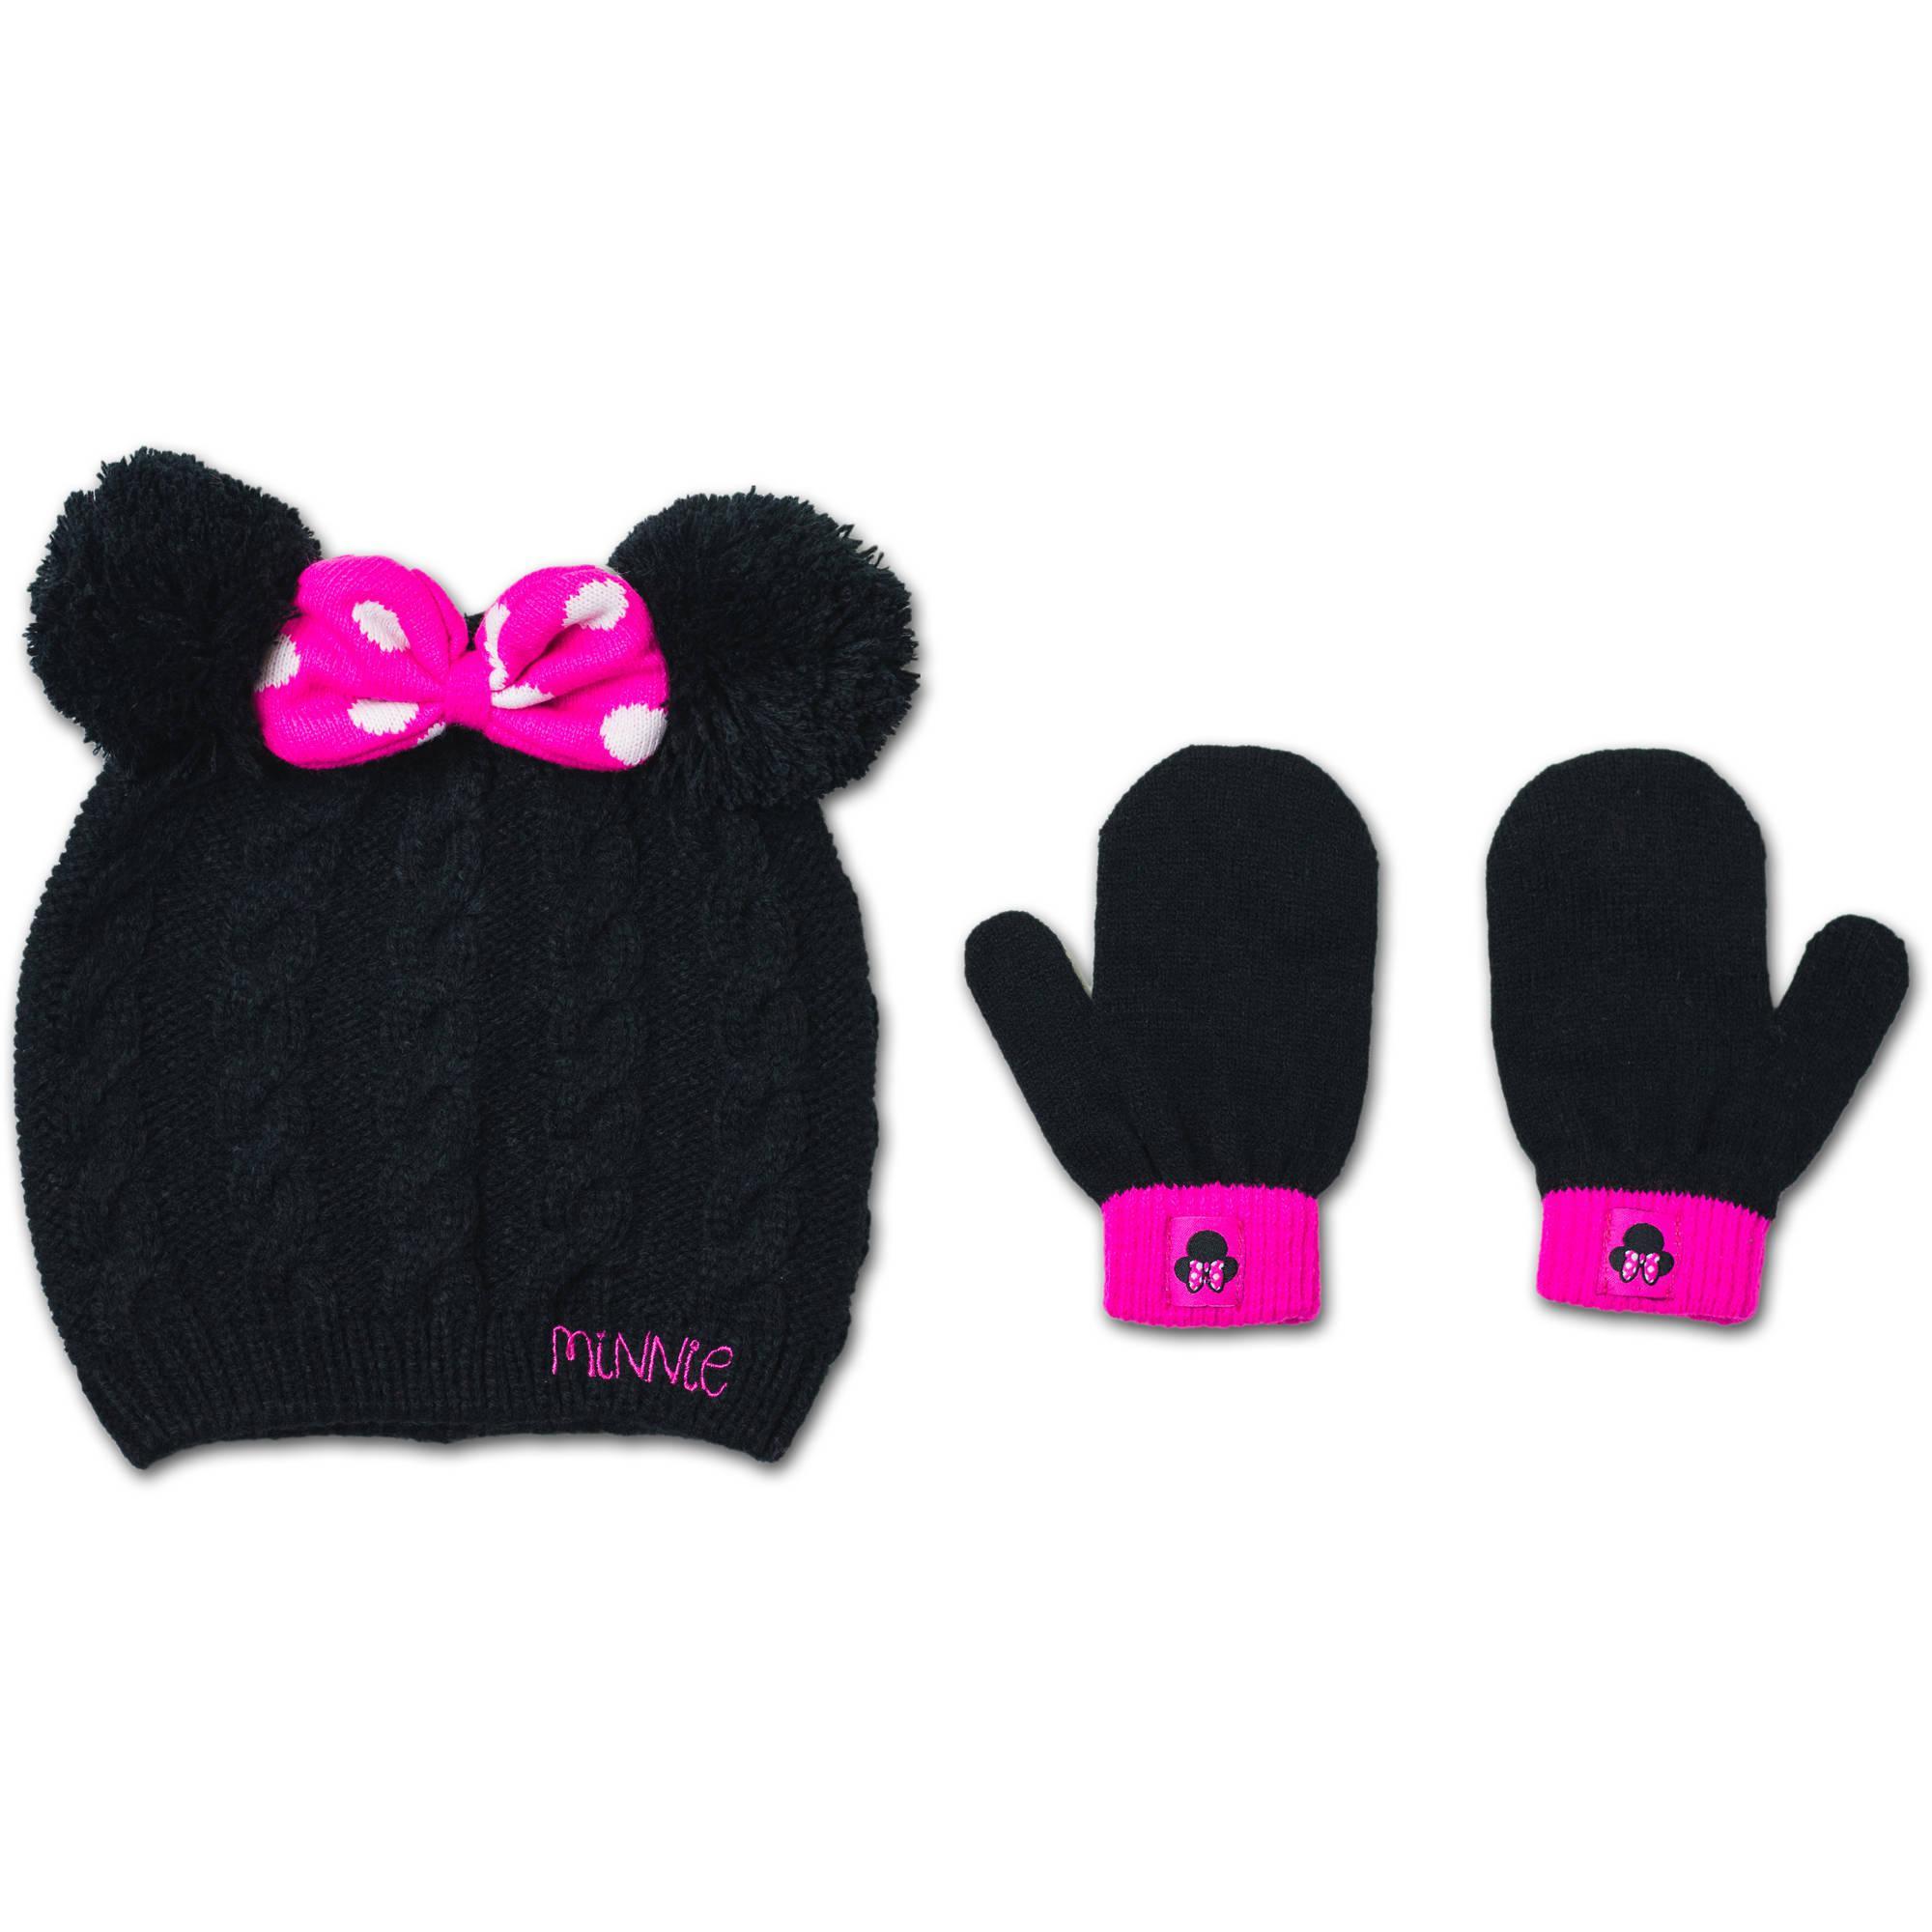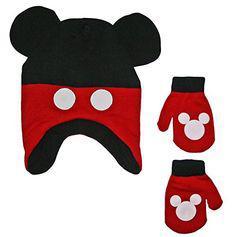The first image is the image on the left, the second image is the image on the right. Given the left and right images, does the statement "Both images in the pair show a winter hat and mittens which are Micky Mouse or Minnie Mouse themed." hold true? Answer yes or no. Yes. The first image is the image on the left, the second image is the image on the right. For the images displayed, is the sentence "The left image includes mittens next to a cap with black ears and pink polka dotted bow, and the right image shows mittens by a cap with black ears and white dots on red." factually correct? Answer yes or no. Yes. 